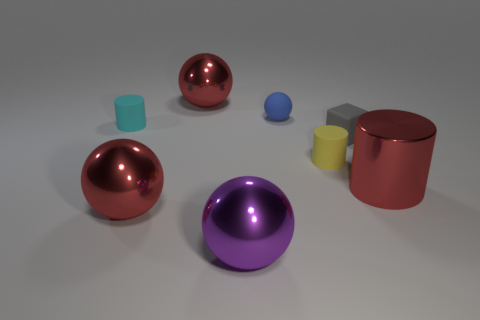How many red balls must be subtracted to get 1 red balls? 1 Subtract all metallic cylinders. How many cylinders are left? 2 Subtract all red cylinders. How many cylinders are left? 2 Subtract all purple spheres. Subtract all red cylinders. How many spheres are left? 3 Subtract all purple balls. How many purple blocks are left? 0 Subtract 0 gray balls. How many objects are left? 8 Subtract all cylinders. How many objects are left? 5 Subtract 3 cylinders. How many cylinders are left? 0 Subtract all tiny brown metallic things. Subtract all blue spheres. How many objects are left? 7 Add 4 tiny blue things. How many tiny blue things are left? 5 